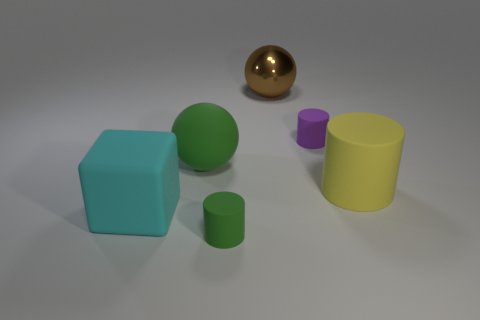If you had to guess, what might be the texture of the objects? Given the visual cues in the image, the objects seem to have a mix of textures: the yellow cylinder and purple cup appear to have a matte finish, the green shapes look slightly velvety, and the golden sphere looks metallic and reflective. 